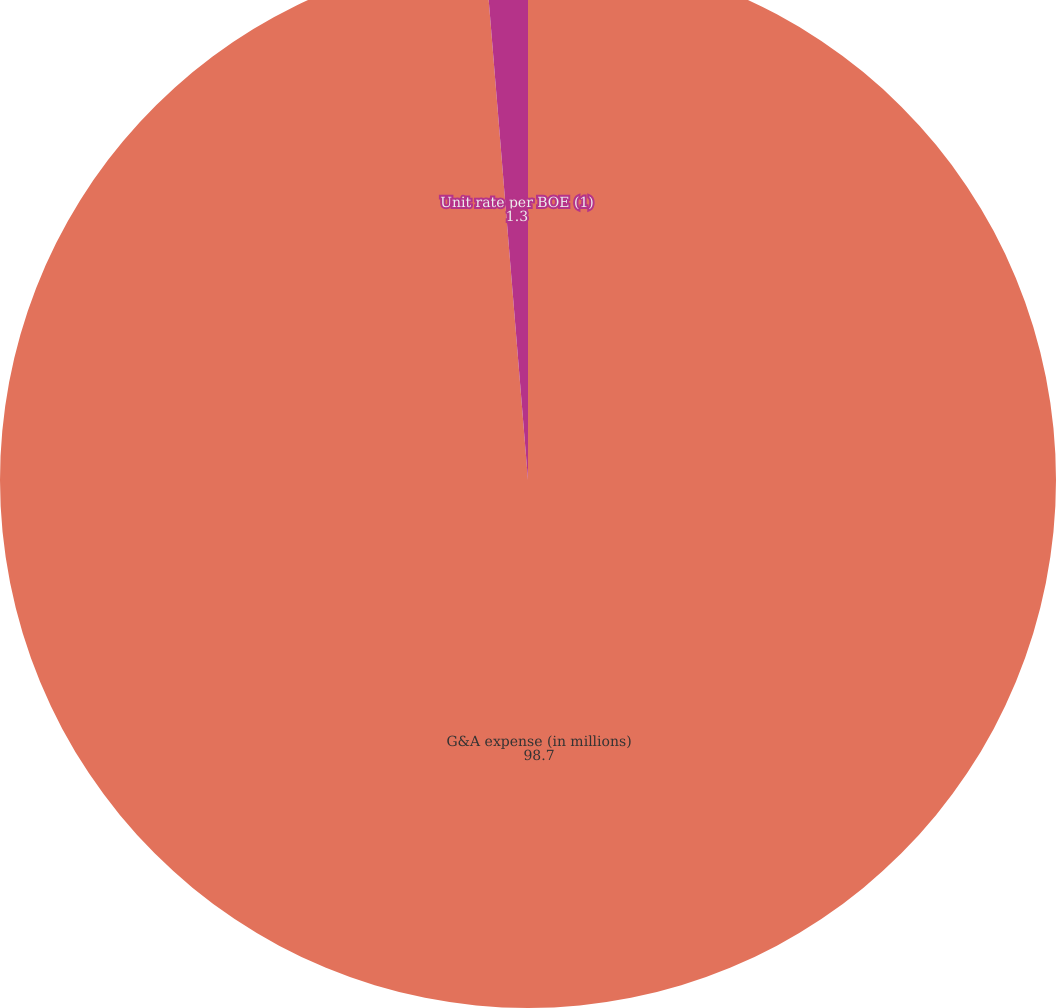Convert chart to OTSL. <chart><loc_0><loc_0><loc_500><loc_500><pie_chart><fcel>G&A expense (in millions)<fcel>Unit rate per BOE (1)<nl><fcel>98.7%<fcel>1.3%<nl></chart> 